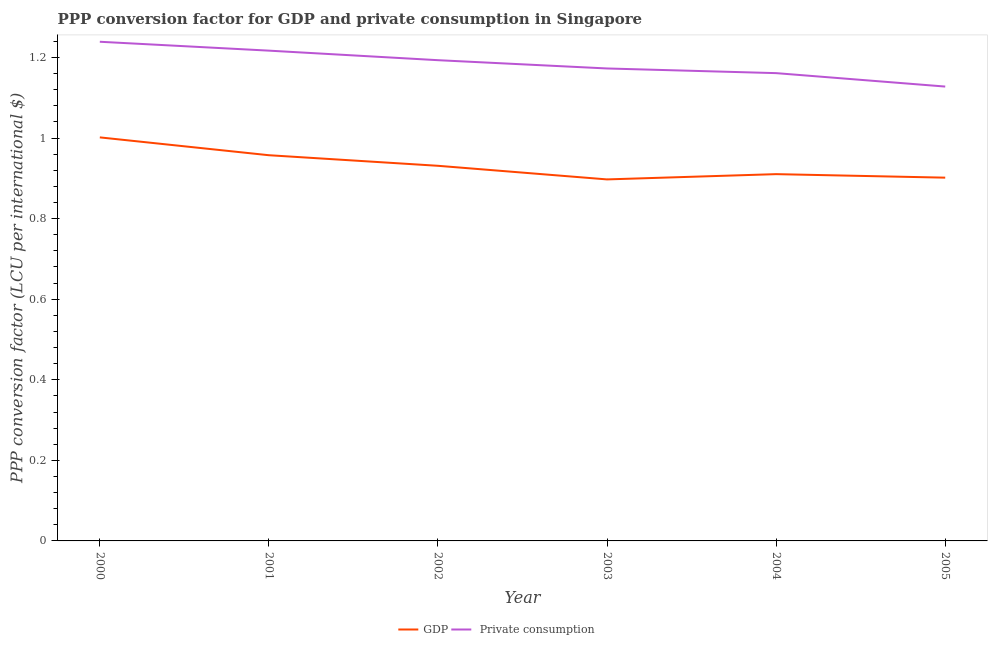How many different coloured lines are there?
Provide a short and direct response. 2. Is the number of lines equal to the number of legend labels?
Keep it short and to the point. Yes. What is the ppp conversion factor for gdp in 2003?
Provide a succinct answer. 0.9. Across all years, what is the maximum ppp conversion factor for gdp?
Offer a terse response. 1. Across all years, what is the minimum ppp conversion factor for private consumption?
Keep it short and to the point. 1.13. What is the total ppp conversion factor for gdp in the graph?
Give a very brief answer. 5.6. What is the difference between the ppp conversion factor for gdp in 2002 and that in 2003?
Your response must be concise. 0.03. What is the difference between the ppp conversion factor for private consumption in 2004 and the ppp conversion factor for gdp in 2005?
Ensure brevity in your answer.  0.26. What is the average ppp conversion factor for gdp per year?
Your response must be concise. 0.93. In the year 2005, what is the difference between the ppp conversion factor for gdp and ppp conversion factor for private consumption?
Your response must be concise. -0.23. In how many years, is the ppp conversion factor for private consumption greater than 0.16 LCU?
Your answer should be very brief. 6. What is the ratio of the ppp conversion factor for gdp in 2002 to that in 2005?
Provide a short and direct response. 1.03. Is the ppp conversion factor for private consumption in 2004 less than that in 2005?
Make the answer very short. No. What is the difference between the highest and the second highest ppp conversion factor for private consumption?
Keep it short and to the point. 0.02. What is the difference between the highest and the lowest ppp conversion factor for private consumption?
Provide a succinct answer. 0.11. Does the ppp conversion factor for gdp monotonically increase over the years?
Your answer should be compact. No. Is the ppp conversion factor for gdp strictly less than the ppp conversion factor for private consumption over the years?
Provide a short and direct response. Yes. How many years are there in the graph?
Offer a very short reply. 6. What is the difference between two consecutive major ticks on the Y-axis?
Your response must be concise. 0.2. Are the values on the major ticks of Y-axis written in scientific E-notation?
Keep it short and to the point. No. What is the title of the graph?
Provide a short and direct response. PPP conversion factor for GDP and private consumption in Singapore. What is the label or title of the Y-axis?
Offer a terse response. PPP conversion factor (LCU per international $). What is the PPP conversion factor (LCU per international $) of GDP in 2000?
Provide a short and direct response. 1. What is the PPP conversion factor (LCU per international $) in  Private consumption in 2000?
Give a very brief answer. 1.24. What is the PPP conversion factor (LCU per international $) of GDP in 2001?
Ensure brevity in your answer.  0.96. What is the PPP conversion factor (LCU per international $) in  Private consumption in 2001?
Your answer should be compact. 1.22. What is the PPP conversion factor (LCU per international $) in GDP in 2002?
Offer a very short reply. 0.93. What is the PPP conversion factor (LCU per international $) in  Private consumption in 2002?
Ensure brevity in your answer.  1.19. What is the PPP conversion factor (LCU per international $) in GDP in 2003?
Your answer should be very brief. 0.9. What is the PPP conversion factor (LCU per international $) of  Private consumption in 2003?
Your response must be concise. 1.17. What is the PPP conversion factor (LCU per international $) of GDP in 2004?
Make the answer very short. 0.91. What is the PPP conversion factor (LCU per international $) of  Private consumption in 2004?
Keep it short and to the point. 1.16. What is the PPP conversion factor (LCU per international $) in GDP in 2005?
Make the answer very short. 0.9. What is the PPP conversion factor (LCU per international $) of  Private consumption in 2005?
Your answer should be compact. 1.13. Across all years, what is the maximum PPP conversion factor (LCU per international $) of GDP?
Make the answer very short. 1. Across all years, what is the maximum PPP conversion factor (LCU per international $) in  Private consumption?
Ensure brevity in your answer.  1.24. Across all years, what is the minimum PPP conversion factor (LCU per international $) in GDP?
Provide a short and direct response. 0.9. Across all years, what is the minimum PPP conversion factor (LCU per international $) of  Private consumption?
Offer a terse response. 1.13. What is the total PPP conversion factor (LCU per international $) in GDP in the graph?
Make the answer very short. 5.6. What is the total PPP conversion factor (LCU per international $) of  Private consumption in the graph?
Your answer should be very brief. 7.11. What is the difference between the PPP conversion factor (LCU per international $) in GDP in 2000 and that in 2001?
Provide a succinct answer. 0.04. What is the difference between the PPP conversion factor (LCU per international $) in  Private consumption in 2000 and that in 2001?
Offer a terse response. 0.02. What is the difference between the PPP conversion factor (LCU per international $) of GDP in 2000 and that in 2002?
Your answer should be very brief. 0.07. What is the difference between the PPP conversion factor (LCU per international $) of  Private consumption in 2000 and that in 2002?
Your answer should be compact. 0.05. What is the difference between the PPP conversion factor (LCU per international $) of GDP in 2000 and that in 2003?
Your response must be concise. 0.1. What is the difference between the PPP conversion factor (LCU per international $) of  Private consumption in 2000 and that in 2003?
Ensure brevity in your answer.  0.07. What is the difference between the PPP conversion factor (LCU per international $) in GDP in 2000 and that in 2004?
Give a very brief answer. 0.09. What is the difference between the PPP conversion factor (LCU per international $) in  Private consumption in 2000 and that in 2004?
Offer a very short reply. 0.08. What is the difference between the PPP conversion factor (LCU per international $) in GDP in 2000 and that in 2005?
Offer a terse response. 0.1. What is the difference between the PPP conversion factor (LCU per international $) in  Private consumption in 2000 and that in 2005?
Ensure brevity in your answer.  0.11. What is the difference between the PPP conversion factor (LCU per international $) in GDP in 2001 and that in 2002?
Offer a terse response. 0.03. What is the difference between the PPP conversion factor (LCU per international $) in  Private consumption in 2001 and that in 2002?
Your response must be concise. 0.02. What is the difference between the PPP conversion factor (LCU per international $) in  Private consumption in 2001 and that in 2003?
Provide a succinct answer. 0.04. What is the difference between the PPP conversion factor (LCU per international $) in GDP in 2001 and that in 2004?
Give a very brief answer. 0.05. What is the difference between the PPP conversion factor (LCU per international $) of  Private consumption in 2001 and that in 2004?
Give a very brief answer. 0.06. What is the difference between the PPP conversion factor (LCU per international $) in GDP in 2001 and that in 2005?
Your answer should be compact. 0.06. What is the difference between the PPP conversion factor (LCU per international $) of  Private consumption in 2001 and that in 2005?
Give a very brief answer. 0.09. What is the difference between the PPP conversion factor (LCU per international $) in GDP in 2002 and that in 2003?
Keep it short and to the point. 0.03. What is the difference between the PPP conversion factor (LCU per international $) of  Private consumption in 2002 and that in 2003?
Offer a terse response. 0.02. What is the difference between the PPP conversion factor (LCU per international $) in GDP in 2002 and that in 2004?
Offer a terse response. 0.02. What is the difference between the PPP conversion factor (LCU per international $) in  Private consumption in 2002 and that in 2004?
Offer a very short reply. 0.03. What is the difference between the PPP conversion factor (LCU per international $) in GDP in 2002 and that in 2005?
Your answer should be compact. 0.03. What is the difference between the PPP conversion factor (LCU per international $) of  Private consumption in 2002 and that in 2005?
Keep it short and to the point. 0.07. What is the difference between the PPP conversion factor (LCU per international $) of GDP in 2003 and that in 2004?
Give a very brief answer. -0.01. What is the difference between the PPP conversion factor (LCU per international $) of  Private consumption in 2003 and that in 2004?
Provide a short and direct response. 0.01. What is the difference between the PPP conversion factor (LCU per international $) in GDP in 2003 and that in 2005?
Ensure brevity in your answer.  -0. What is the difference between the PPP conversion factor (LCU per international $) in  Private consumption in 2003 and that in 2005?
Ensure brevity in your answer.  0.04. What is the difference between the PPP conversion factor (LCU per international $) in GDP in 2004 and that in 2005?
Your answer should be compact. 0.01. What is the difference between the PPP conversion factor (LCU per international $) in  Private consumption in 2004 and that in 2005?
Your response must be concise. 0.03. What is the difference between the PPP conversion factor (LCU per international $) of GDP in 2000 and the PPP conversion factor (LCU per international $) of  Private consumption in 2001?
Your response must be concise. -0.22. What is the difference between the PPP conversion factor (LCU per international $) of GDP in 2000 and the PPP conversion factor (LCU per international $) of  Private consumption in 2002?
Give a very brief answer. -0.19. What is the difference between the PPP conversion factor (LCU per international $) of GDP in 2000 and the PPP conversion factor (LCU per international $) of  Private consumption in 2003?
Your answer should be compact. -0.17. What is the difference between the PPP conversion factor (LCU per international $) in GDP in 2000 and the PPP conversion factor (LCU per international $) in  Private consumption in 2004?
Provide a succinct answer. -0.16. What is the difference between the PPP conversion factor (LCU per international $) of GDP in 2000 and the PPP conversion factor (LCU per international $) of  Private consumption in 2005?
Offer a very short reply. -0.13. What is the difference between the PPP conversion factor (LCU per international $) of GDP in 2001 and the PPP conversion factor (LCU per international $) of  Private consumption in 2002?
Provide a short and direct response. -0.24. What is the difference between the PPP conversion factor (LCU per international $) in GDP in 2001 and the PPP conversion factor (LCU per international $) in  Private consumption in 2003?
Provide a succinct answer. -0.22. What is the difference between the PPP conversion factor (LCU per international $) in GDP in 2001 and the PPP conversion factor (LCU per international $) in  Private consumption in 2004?
Offer a very short reply. -0.2. What is the difference between the PPP conversion factor (LCU per international $) in GDP in 2001 and the PPP conversion factor (LCU per international $) in  Private consumption in 2005?
Your answer should be compact. -0.17. What is the difference between the PPP conversion factor (LCU per international $) in GDP in 2002 and the PPP conversion factor (LCU per international $) in  Private consumption in 2003?
Your response must be concise. -0.24. What is the difference between the PPP conversion factor (LCU per international $) in GDP in 2002 and the PPP conversion factor (LCU per international $) in  Private consumption in 2004?
Make the answer very short. -0.23. What is the difference between the PPP conversion factor (LCU per international $) in GDP in 2002 and the PPP conversion factor (LCU per international $) in  Private consumption in 2005?
Provide a succinct answer. -0.2. What is the difference between the PPP conversion factor (LCU per international $) in GDP in 2003 and the PPP conversion factor (LCU per international $) in  Private consumption in 2004?
Your response must be concise. -0.26. What is the difference between the PPP conversion factor (LCU per international $) in GDP in 2003 and the PPP conversion factor (LCU per international $) in  Private consumption in 2005?
Offer a very short reply. -0.23. What is the difference between the PPP conversion factor (LCU per international $) in GDP in 2004 and the PPP conversion factor (LCU per international $) in  Private consumption in 2005?
Provide a succinct answer. -0.22. What is the average PPP conversion factor (LCU per international $) of GDP per year?
Offer a terse response. 0.93. What is the average PPP conversion factor (LCU per international $) of  Private consumption per year?
Your answer should be very brief. 1.19. In the year 2000, what is the difference between the PPP conversion factor (LCU per international $) in GDP and PPP conversion factor (LCU per international $) in  Private consumption?
Make the answer very short. -0.24. In the year 2001, what is the difference between the PPP conversion factor (LCU per international $) in GDP and PPP conversion factor (LCU per international $) in  Private consumption?
Your response must be concise. -0.26. In the year 2002, what is the difference between the PPP conversion factor (LCU per international $) of GDP and PPP conversion factor (LCU per international $) of  Private consumption?
Your answer should be very brief. -0.26. In the year 2003, what is the difference between the PPP conversion factor (LCU per international $) in GDP and PPP conversion factor (LCU per international $) in  Private consumption?
Make the answer very short. -0.28. In the year 2004, what is the difference between the PPP conversion factor (LCU per international $) in GDP and PPP conversion factor (LCU per international $) in  Private consumption?
Your answer should be very brief. -0.25. In the year 2005, what is the difference between the PPP conversion factor (LCU per international $) of GDP and PPP conversion factor (LCU per international $) of  Private consumption?
Offer a very short reply. -0.23. What is the ratio of the PPP conversion factor (LCU per international $) in GDP in 2000 to that in 2001?
Offer a terse response. 1.05. What is the ratio of the PPP conversion factor (LCU per international $) of  Private consumption in 2000 to that in 2001?
Provide a short and direct response. 1.02. What is the ratio of the PPP conversion factor (LCU per international $) in GDP in 2000 to that in 2002?
Your response must be concise. 1.08. What is the ratio of the PPP conversion factor (LCU per international $) in  Private consumption in 2000 to that in 2002?
Offer a very short reply. 1.04. What is the ratio of the PPP conversion factor (LCU per international $) of GDP in 2000 to that in 2003?
Offer a terse response. 1.12. What is the ratio of the PPP conversion factor (LCU per international $) of  Private consumption in 2000 to that in 2003?
Provide a succinct answer. 1.06. What is the ratio of the PPP conversion factor (LCU per international $) in GDP in 2000 to that in 2004?
Give a very brief answer. 1.1. What is the ratio of the PPP conversion factor (LCU per international $) of  Private consumption in 2000 to that in 2004?
Give a very brief answer. 1.07. What is the ratio of the PPP conversion factor (LCU per international $) of GDP in 2000 to that in 2005?
Your answer should be very brief. 1.11. What is the ratio of the PPP conversion factor (LCU per international $) in  Private consumption in 2000 to that in 2005?
Your answer should be compact. 1.1. What is the ratio of the PPP conversion factor (LCU per international $) in GDP in 2001 to that in 2002?
Provide a succinct answer. 1.03. What is the ratio of the PPP conversion factor (LCU per international $) in  Private consumption in 2001 to that in 2002?
Ensure brevity in your answer.  1.02. What is the ratio of the PPP conversion factor (LCU per international $) of GDP in 2001 to that in 2003?
Your response must be concise. 1.07. What is the ratio of the PPP conversion factor (LCU per international $) in  Private consumption in 2001 to that in 2003?
Offer a very short reply. 1.04. What is the ratio of the PPP conversion factor (LCU per international $) in GDP in 2001 to that in 2004?
Offer a terse response. 1.05. What is the ratio of the PPP conversion factor (LCU per international $) in  Private consumption in 2001 to that in 2004?
Ensure brevity in your answer.  1.05. What is the ratio of the PPP conversion factor (LCU per international $) in GDP in 2001 to that in 2005?
Offer a terse response. 1.06. What is the ratio of the PPP conversion factor (LCU per international $) in  Private consumption in 2001 to that in 2005?
Offer a terse response. 1.08. What is the ratio of the PPP conversion factor (LCU per international $) in GDP in 2002 to that in 2003?
Your response must be concise. 1.04. What is the ratio of the PPP conversion factor (LCU per international $) in  Private consumption in 2002 to that in 2003?
Offer a very short reply. 1.02. What is the ratio of the PPP conversion factor (LCU per international $) in GDP in 2002 to that in 2004?
Offer a terse response. 1.02. What is the ratio of the PPP conversion factor (LCU per international $) in  Private consumption in 2002 to that in 2004?
Offer a terse response. 1.03. What is the ratio of the PPP conversion factor (LCU per international $) in GDP in 2002 to that in 2005?
Your response must be concise. 1.03. What is the ratio of the PPP conversion factor (LCU per international $) of  Private consumption in 2002 to that in 2005?
Keep it short and to the point. 1.06. What is the ratio of the PPP conversion factor (LCU per international $) of GDP in 2003 to that in 2004?
Provide a succinct answer. 0.99. What is the ratio of the PPP conversion factor (LCU per international $) of  Private consumption in 2003 to that in 2004?
Provide a short and direct response. 1.01. What is the ratio of the PPP conversion factor (LCU per international $) of GDP in 2003 to that in 2005?
Your answer should be very brief. 1. What is the ratio of the PPP conversion factor (LCU per international $) of  Private consumption in 2003 to that in 2005?
Offer a terse response. 1.04. What is the ratio of the PPP conversion factor (LCU per international $) in GDP in 2004 to that in 2005?
Your response must be concise. 1.01. What is the ratio of the PPP conversion factor (LCU per international $) in  Private consumption in 2004 to that in 2005?
Offer a very short reply. 1.03. What is the difference between the highest and the second highest PPP conversion factor (LCU per international $) in GDP?
Provide a succinct answer. 0.04. What is the difference between the highest and the second highest PPP conversion factor (LCU per international $) in  Private consumption?
Your answer should be very brief. 0.02. What is the difference between the highest and the lowest PPP conversion factor (LCU per international $) of GDP?
Your response must be concise. 0.1. What is the difference between the highest and the lowest PPP conversion factor (LCU per international $) of  Private consumption?
Your answer should be compact. 0.11. 